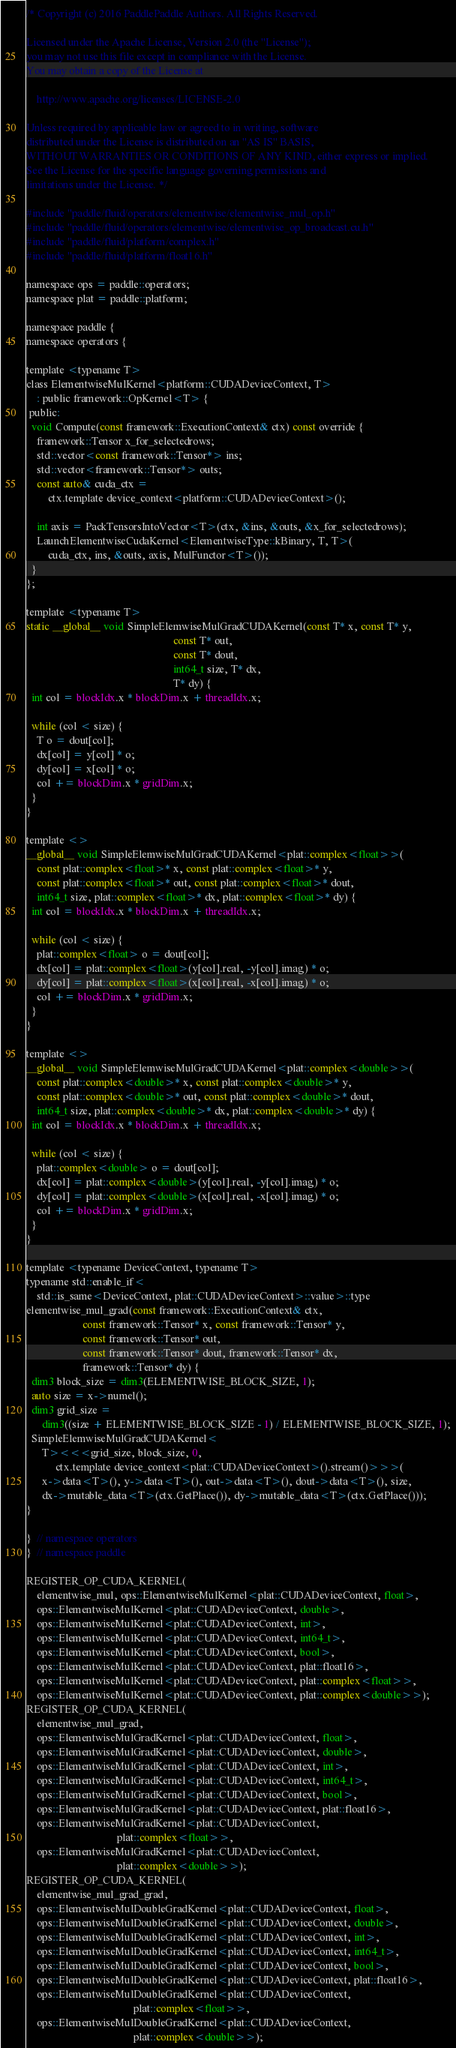Convert code to text. <code><loc_0><loc_0><loc_500><loc_500><_Cuda_>/* Copyright (c) 2016 PaddlePaddle Authors. All Rights Reserved.

Licensed under the Apache License, Version 2.0 (the "License");
you may not use this file except in compliance with the License.
You may obtain a copy of the License at

    http://www.apache.org/licenses/LICENSE-2.0

Unless required by applicable law or agreed to in writing, software
distributed under the License is distributed on an "AS IS" BASIS,
WITHOUT WARRANTIES OR CONDITIONS OF ANY KIND, either express or implied.
See the License for the specific language governing permissions and
limitations under the License. */

#include "paddle/fluid/operators/elementwise/elementwise_mul_op.h"
#include "paddle/fluid/operators/elementwise/elementwise_op_broadcast.cu.h"
#include "paddle/fluid/platform/complex.h"
#include "paddle/fluid/platform/float16.h"

namespace ops = paddle::operators;
namespace plat = paddle::platform;

namespace paddle {
namespace operators {

template <typename T>
class ElementwiseMulKernel<platform::CUDADeviceContext, T>
    : public framework::OpKernel<T> {
 public:
  void Compute(const framework::ExecutionContext& ctx) const override {
    framework::Tensor x_for_selectedrows;
    std::vector<const framework::Tensor*> ins;
    std::vector<framework::Tensor*> outs;
    const auto& cuda_ctx =
        ctx.template device_context<platform::CUDADeviceContext>();

    int axis = PackTensorsIntoVector<T>(ctx, &ins, &outs, &x_for_selectedrows);
    LaunchElementwiseCudaKernel<ElementwiseType::kBinary, T, T>(
        cuda_ctx, ins, &outs, axis, MulFunctor<T>());
  }
};

template <typename T>
static __global__ void SimpleElemwiseMulGradCUDAKernel(const T* x, const T* y,
                                                       const T* out,
                                                       const T* dout,
                                                       int64_t size, T* dx,
                                                       T* dy) {
  int col = blockIdx.x * blockDim.x + threadIdx.x;

  while (col < size) {
    T o = dout[col];
    dx[col] = y[col] * o;
    dy[col] = x[col] * o;
    col += blockDim.x * gridDim.x;
  }
}

template <>
__global__ void SimpleElemwiseMulGradCUDAKernel<plat::complex<float>>(
    const plat::complex<float>* x, const plat::complex<float>* y,
    const plat::complex<float>* out, const plat::complex<float>* dout,
    int64_t size, plat::complex<float>* dx, plat::complex<float>* dy) {
  int col = blockIdx.x * blockDim.x + threadIdx.x;

  while (col < size) {
    plat::complex<float> o = dout[col];
    dx[col] = plat::complex<float>(y[col].real, -y[col].imag) * o;
    dy[col] = plat::complex<float>(x[col].real, -x[col].imag) * o;
    col += blockDim.x * gridDim.x;
  }
}

template <>
__global__ void SimpleElemwiseMulGradCUDAKernel<plat::complex<double>>(
    const plat::complex<double>* x, const plat::complex<double>* y,
    const plat::complex<double>* out, const plat::complex<double>* dout,
    int64_t size, plat::complex<double>* dx, plat::complex<double>* dy) {
  int col = blockIdx.x * blockDim.x + threadIdx.x;

  while (col < size) {
    plat::complex<double> o = dout[col];
    dx[col] = plat::complex<double>(y[col].real, -y[col].imag) * o;
    dy[col] = plat::complex<double>(x[col].real, -x[col].imag) * o;
    col += blockDim.x * gridDim.x;
  }
}

template <typename DeviceContext, typename T>
typename std::enable_if<
    std::is_same<DeviceContext, plat::CUDADeviceContext>::value>::type
elementwise_mul_grad(const framework::ExecutionContext& ctx,
                     const framework::Tensor* x, const framework::Tensor* y,
                     const framework::Tensor* out,
                     const framework::Tensor* dout, framework::Tensor* dx,
                     framework::Tensor* dy) {
  dim3 block_size = dim3(ELEMENTWISE_BLOCK_SIZE, 1);
  auto size = x->numel();
  dim3 grid_size =
      dim3((size + ELEMENTWISE_BLOCK_SIZE - 1) / ELEMENTWISE_BLOCK_SIZE, 1);
  SimpleElemwiseMulGradCUDAKernel<
      T><<<grid_size, block_size, 0,
           ctx.template device_context<plat::CUDADeviceContext>().stream()>>>(
      x->data<T>(), y->data<T>(), out->data<T>(), dout->data<T>(), size,
      dx->mutable_data<T>(ctx.GetPlace()), dy->mutable_data<T>(ctx.GetPlace()));
}

}  // namespace operators
}  // namespace paddle

REGISTER_OP_CUDA_KERNEL(
    elementwise_mul, ops::ElementwiseMulKernel<plat::CUDADeviceContext, float>,
    ops::ElementwiseMulKernel<plat::CUDADeviceContext, double>,
    ops::ElementwiseMulKernel<plat::CUDADeviceContext, int>,
    ops::ElementwiseMulKernel<plat::CUDADeviceContext, int64_t>,
    ops::ElementwiseMulKernel<plat::CUDADeviceContext, bool>,
    ops::ElementwiseMulKernel<plat::CUDADeviceContext, plat::float16>,
    ops::ElementwiseMulKernel<plat::CUDADeviceContext, plat::complex<float>>,
    ops::ElementwiseMulKernel<plat::CUDADeviceContext, plat::complex<double>>);
REGISTER_OP_CUDA_KERNEL(
    elementwise_mul_grad,
    ops::ElementwiseMulGradKernel<plat::CUDADeviceContext, float>,
    ops::ElementwiseMulGradKernel<plat::CUDADeviceContext, double>,
    ops::ElementwiseMulGradKernel<plat::CUDADeviceContext, int>,
    ops::ElementwiseMulGradKernel<plat::CUDADeviceContext, int64_t>,
    ops::ElementwiseMulGradKernel<plat::CUDADeviceContext, bool>,
    ops::ElementwiseMulGradKernel<plat::CUDADeviceContext, plat::float16>,
    ops::ElementwiseMulGradKernel<plat::CUDADeviceContext,
                                  plat::complex<float>>,
    ops::ElementwiseMulGradKernel<plat::CUDADeviceContext,
                                  plat::complex<double>>);
REGISTER_OP_CUDA_KERNEL(
    elementwise_mul_grad_grad,
    ops::ElementwiseMulDoubleGradKernel<plat::CUDADeviceContext, float>,
    ops::ElementwiseMulDoubleGradKernel<plat::CUDADeviceContext, double>,
    ops::ElementwiseMulDoubleGradKernel<plat::CUDADeviceContext, int>,
    ops::ElementwiseMulDoubleGradKernel<plat::CUDADeviceContext, int64_t>,
    ops::ElementwiseMulDoubleGradKernel<plat::CUDADeviceContext, bool>,
    ops::ElementwiseMulDoubleGradKernel<plat::CUDADeviceContext, plat::float16>,
    ops::ElementwiseMulDoubleGradKernel<plat::CUDADeviceContext,
                                        plat::complex<float>>,
    ops::ElementwiseMulDoubleGradKernel<plat::CUDADeviceContext,
                                        plat::complex<double>>);
</code> 